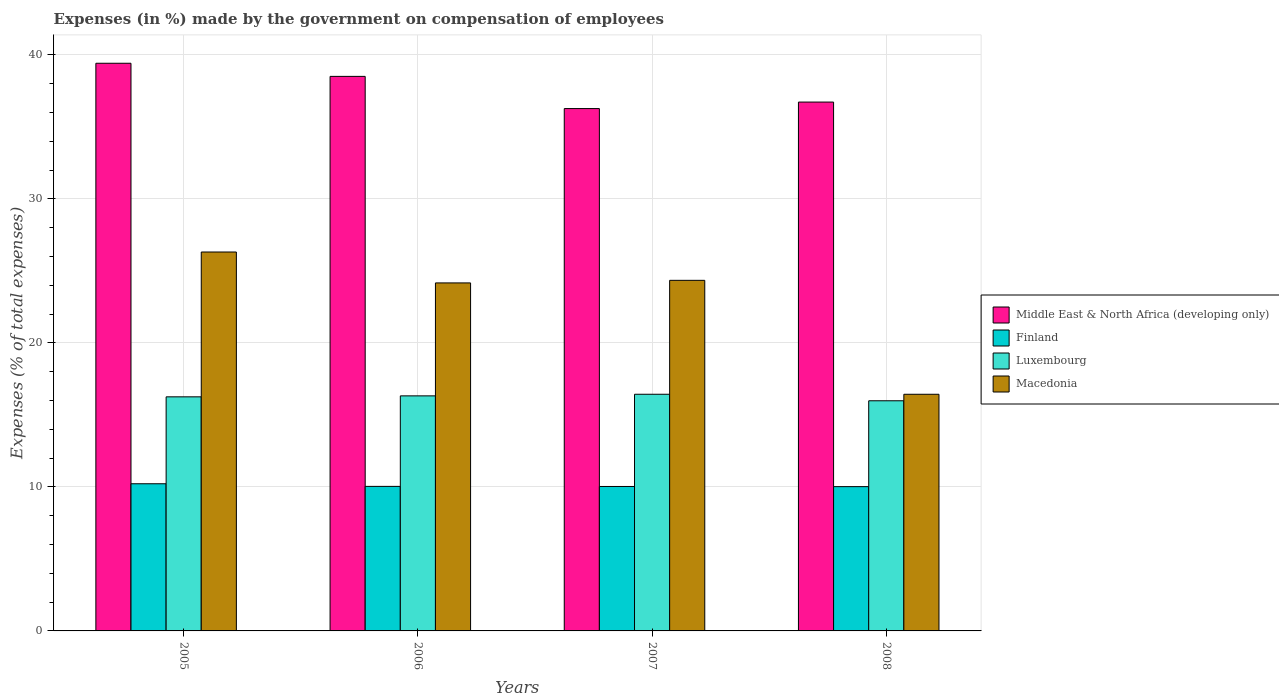Are the number of bars per tick equal to the number of legend labels?
Keep it short and to the point. Yes. Are the number of bars on each tick of the X-axis equal?
Offer a terse response. Yes. How many bars are there on the 4th tick from the right?
Keep it short and to the point. 4. In how many cases, is the number of bars for a given year not equal to the number of legend labels?
Your answer should be very brief. 0. What is the percentage of expenses made by the government on compensation of employees in Middle East & North Africa (developing only) in 2008?
Provide a succinct answer. 36.72. Across all years, what is the maximum percentage of expenses made by the government on compensation of employees in Luxembourg?
Provide a succinct answer. 16.43. Across all years, what is the minimum percentage of expenses made by the government on compensation of employees in Luxembourg?
Offer a terse response. 15.98. In which year was the percentage of expenses made by the government on compensation of employees in Luxembourg maximum?
Offer a very short reply. 2007. In which year was the percentage of expenses made by the government on compensation of employees in Macedonia minimum?
Offer a very short reply. 2008. What is the total percentage of expenses made by the government on compensation of employees in Luxembourg in the graph?
Your answer should be very brief. 64.99. What is the difference between the percentage of expenses made by the government on compensation of employees in Macedonia in 2005 and that in 2008?
Offer a very short reply. 9.88. What is the difference between the percentage of expenses made by the government on compensation of employees in Middle East & North Africa (developing only) in 2008 and the percentage of expenses made by the government on compensation of employees in Finland in 2006?
Keep it short and to the point. 26.68. What is the average percentage of expenses made by the government on compensation of employees in Finland per year?
Make the answer very short. 10.08. In the year 2005, what is the difference between the percentage of expenses made by the government on compensation of employees in Middle East & North Africa (developing only) and percentage of expenses made by the government on compensation of employees in Luxembourg?
Provide a succinct answer. 23.16. What is the ratio of the percentage of expenses made by the government on compensation of employees in Middle East & North Africa (developing only) in 2006 to that in 2007?
Give a very brief answer. 1.06. What is the difference between the highest and the second highest percentage of expenses made by the government on compensation of employees in Middle East & North Africa (developing only)?
Keep it short and to the point. 0.91. What is the difference between the highest and the lowest percentage of expenses made by the government on compensation of employees in Luxembourg?
Ensure brevity in your answer.  0.45. In how many years, is the percentage of expenses made by the government on compensation of employees in Luxembourg greater than the average percentage of expenses made by the government on compensation of employees in Luxembourg taken over all years?
Offer a very short reply. 3. Is the sum of the percentage of expenses made by the government on compensation of employees in Middle East & North Africa (developing only) in 2005 and 2007 greater than the maximum percentage of expenses made by the government on compensation of employees in Macedonia across all years?
Offer a terse response. Yes. What does the 1st bar from the left in 2005 represents?
Provide a short and direct response. Middle East & North Africa (developing only). What does the 2nd bar from the right in 2006 represents?
Your response must be concise. Luxembourg. Are all the bars in the graph horizontal?
Your answer should be very brief. No. Does the graph contain grids?
Keep it short and to the point. Yes. What is the title of the graph?
Keep it short and to the point. Expenses (in %) made by the government on compensation of employees. What is the label or title of the X-axis?
Your answer should be compact. Years. What is the label or title of the Y-axis?
Offer a terse response. Expenses (% of total expenses). What is the Expenses (% of total expenses) in Middle East & North Africa (developing only) in 2005?
Provide a short and direct response. 39.41. What is the Expenses (% of total expenses) in Finland in 2005?
Your answer should be very brief. 10.22. What is the Expenses (% of total expenses) of Luxembourg in 2005?
Your answer should be compact. 16.25. What is the Expenses (% of total expenses) in Macedonia in 2005?
Offer a terse response. 26.31. What is the Expenses (% of total expenses) in Middle East & North Africa (developing only) in 2006?
Your answer should be very brief. 38.5. What is the Expenses (% of total expenses) in Finland in 2006?
Make the answer very short. 10.04. What is the Expenses (% of total expenses) in Luxembourg in 2006?
Your answer should be very brief. 16.32. What is the Expenses (% of total expenses) in Macedonia in 2006?
Your response must be concise. 24.16. What is the Expenses (% of total expenses) of Middle East & North Africa (developing only) in 2007?
Give a very brief answer. 36.27. What is the Expenses (% of total expenses) of Finland in 2007?
Your answer should be very brief. 10.03. What is the Expenses (% of total expenses) in Luxembourg in 2007?
Your answer should be compact. 16.43. What is the Expenses (% of total expenses) in Macedonia in 2007?
Provide a short and direct response. 24.34. What is the Expenses (% of total expenses) in Middle East & North Africa (developing only) in 2008?
Offer a terse response. 36.72. What is the Expenses (% of total expenses) in Finland in 2008?
Ensure brevity in your answer.  10.02. What is the Expenses (% of total expenses) of Luxembourg in 2008?
Ensure brevity in your answer.  15.98. What is the Expenses (% of total expenses) in Macedonia in 2008?
Give a very brief answer. 16.43. Across all years, what is the maximum Expenses (% of total expenses) of Middle East & North Africa (developing only)?
Offer a very short reply. 39.41. Across all years, what is the maximum Expenses (% of total expenses) of Finland?
Provide a succinct answer. 10.22. Across all years, what is the maximum Expenses (% of total expenses) of Luxembourg?
Give a very brief answer. 16.43. Across all years, what is the maximum Expenses (% of total expenses) in Macedonia?
Keep it short and to the point. 26.31. Across all years, what is the minimum Expenses (% of total expenses) in Middle East & North Africa (developing only)?
Keep it short and to the point. 36.27. Across all years, what is the minimum Expenses (% of total expenses) in Finland?
Keep it short and to the point. 10.02. Across all years, what is the minimum Expenses (% of total expenses) of Luxembourg?
Offer a very short reply. 15.98. Across all years, what is the minimum Expenses (% of total expenses) of Macedonia?
Make the answer very short. 16.43. What is the total Expenses (% of total expenses) of Middle East & North Africa (developing only) in the graph?
Give a very brief answer. 150.91. What is the total Expenses (% of total expenses) of Finland in the graph?
Keep it short and to the point. 40.3. What is the total Expenses (% of total expenses) in Luxembourg in the graph?
Your response must be concise. 64.99. What is the total Expenses (% of total expenses) of Macedonia in the graph?
Make the answer very short. 91.25. What is the difference between the Expenses (% of total expenses) in Middle East & North Africa (developing only) in 2005 and that in 2006?
Provide a short and direct response. 0.91. What is the difference between the Expenses (% of total expenses) of Finland in 2005 and that in 2006?
Provide a short and direct response. 0.18. What is the difference between the Expenses (% of total expenses) in Luxembourg in 2005 and that in 2006?
Your answer should be very brief. -0.07. What is the difference between the Expenses (% of total expenses) in Macedonia in 2005 and that in 2006?
Provide a short and direct response. 2.15. What is the difference between the Expenses (% of total expenses) in Middle East & North Africa (developing only) in 2005 and that in 2007?
Offer a very short reply. 3.15. What is the difference between the Expenses (% of total expenses) in Finland in 2005 and that in 2007?
Keep it short and to the point. 0.19. What is the difference between the Expenses (% of total expenses) of Luxembourg in 2005 and that in 2007?
Offer a terse response. -0.18. What is the difference between the Expenses (% of total expenses) in Macedonia in 2005 and that in 2007?
Make the answer very short. 1.97. What is the difference between the Expenses (% of total expenses) in Middle East & North Africa (developing only) in 2005 and that in 2008?
Ensure brevity in your answer.  2.69. What is the difference between the Expenses (% of total expenses) in Finland in 2005 and that in 2008?
Provide a succinct answer. 0.2. What is the difference between the Expenses (% of total expenses) in Luxembourg in 2005 and that in 2008?
Your response must be concise. 0.27. What is the difference between the Expenses (% of total expenses) of Macedonia in 2005 and that in 2008?
Your response must be concise. 9.88. What is the difference between the Expenses (% of total expenses) of Middle East & North Africa (developing only) in 2006 and that in 2007?
Your response must be concise. 2.23. What is the difference between the Expenses (% of total expenses) in Finland in 2006 and that in 2007?
Your response must be concise. 0.01. What is the difference between the Expenses (% of total expenses) of Luxembourg in 2006 and that in 2007?
Keep it short and to the point. -0.11. What is the difference between the Expenses (% of total expenses) of Macedonia in 2006 and that in 2007?
Ensure brevity in your answer.  -0.18. What is the difference between the Expenses (% of total expenses) in Middle East & North Africa (developing only) in 2006 and that in 2008?
Give a very brief answer. 1.78. What is the difference between the Expenses (% of total expenses) in Finland in 2006 and that in 2008?
Make the answer very short. 0.02. What is the difference between the Expenses (% of total expenses) in Luxembourg in 2006 and that in 2008?
Your answer should be compact. 0.34. What is the difference between the Expenses (% of total expenses) of Macedonia in 2006 and that in 2008?
Your answer should be very brief. 7.73. What is the difference between the Expenses (% of total expenses) in Middle East & North Africa (developing only) in 2007 and that in 2008?
Your response must be concise. -0.45. What is the difference between the Expenses (% of total expenses) of Finland in 2007 and that in 2008?
Offer a very short reply. 0.01. What is the difference between the Expenses (% of total expenses) in Luxembourg in 2007 and that in 2008?
Offer a very short reply. 0.45. What is the difference between the Expenses (% of total expenses) of Macedonia in 2007 and that in 2008?
Provide a succinct answer. 7.91. What is the difference between the Expenses (% of total expenses) in Middle East & North Africa (developing only) in 2005 and the Expenses (% of total expenses) in Finland in 2006?
Give a very brief answer. 29.38. What is the difference between the Expenses (% of total expenses) in Middle East & North Africa (developing only) in 2005 and the Expenses (% of total expenses) in Luxembourg in 2006?
Provide a succinct answer. 23.09. What is the difference between the Expenses (% of total expenses) of Middle East & North Africa (developing only) in 2005 and the Expenses (% of total expenses) of Macedonia in 2006?
Give a very brief answer. 15.25. What is the difference between the Expenses (% of total expenses) in Finland in 2005 and the Expenses (% of total expenses) in Luxembourg in 2006?
Keep it short and to the point. -6.1. What is the difference between the Expenses (% of total expenses) in Finland in 2005 and the Expenses (% of total expenses) in Macedonia in 2006?
Your answer should be very brief. -13.95. What is the difference between the Expenses (% of total expenses) of Luxembourg in 2005 and the Expenses (% of total expenses) of Macedonia in 2006?
Your answer should be compact. -7.91. What is the difference between the Expenses (% of total expenses) in Middle East & North Africa (developing only) in 2005 and the Expenses (% of total expenses) in Finland in 2007?
Offer a very short reply. 29.39. What is the difference between the Expenses (% of total expenses) in Middle East & North Africa (developing only) in 2005 and the Expenses (% of total expenses) in Luxembourg in 2007?
Offer a terse response. 22.98. What is the difference between the Expenses (% of total expenses) in Middle East & North Africa (developing only) in 2005 and the Expenses (% of total expenses) in Macedonia in 2007?
Provide a short and direct response. 15.07. What is the difference between the Expenses (% of total expenses) in Finland in 2005 and the Expenses (% of total expenses) in Luxembourg in 2007?
Make the answer very short. -6.21. What is the difference between the Expenses (% of total expenses) of Finland in 2005 and the Expenses (% of total expenses) of Macedonia in 2007?
Offer a terse response. -14.12. What is the difference between the Expenses (% of total expenses) in Luxembourg in 2005 and the Expenses (% of total expenses) in Macedonia in 2007?
Offer a terse response. -8.09. What is the difference between the Expenses (% of total expenses) of Middle East & North Africa (developing only) in 2005 and the Expenses (% of total expenses) of Finland in 2008?
Offer a terse response. 29.4. What is the difference between the Expenses (% of total expenses) of Middle East & North Africa (developing only) in 2005 and the Expenses (% of total expenses) of Luxembourg in 2008?
Keep it short and to the point. 23.44. What is the difference between the Expenses (% of total expenses) of Middle East & North Africa (developing only) in 2005 and the Expenses (% of total expenses) of Macedonia in 2008?
Your answer should be compact. 22.98. What is the difference between the Expenses (% of total expenses) of Finland in 2005 and the Expenses (% of total expenses) of Luxembourg in 2008?
Give a very brief answer. -5.76. What is the difference between the Expenses (% of total expenses) in Finland in 2005 and the Expenses (% of total expenses) in Macedonia in 2008?
Ensure brevity in your answer.  -6.21. What is the difference between the Expenses (% of total expenses) in Luxembourg in 2005 and the Expenses (% of total expenses) in Macedonia in 2008?
Keep it short and to the point. -0.18. What is the difference between the Expenses (% of total expenses) in Middle East & North Africa (developing only) in 2006 and the Expenses (% of total expenses) in Finland in 2007?
Make the answer very short. 28.47. What is the difference between the Expenses (% of total expenses) in Middle East & North Africa (developing only) in 2006 and the Expenses (% of total expenses) in Luxembourg in 2007?
Your answer should be compact. 22.07. What is the difference between the Expenses (% of total expenses) of Middle East & North Africa (developing only) in 2006 and the Expenses (% of total expenses) of Macedonia in 2007?
Give a very brief answer. 14.16. What is the difference between the Expenses (% of total expenses) in Finland in 2006 and the Expenses (% of total expenses) in Luxembourg in 2007?
Offer a very short reply. -6.4. What is the difference between the Expenses (% of total expenses) of Finland in 2006 and the Expenses (% of total expenses) of Macedonia in 2007?
Give a very brief answer. -14.31. What is the difference between the Expenses (% of total expenses) in Luxembourg in 2006 and the Expenses (% of total expenses) in Macedonia in 2007?
Keep it short and to the point. -8.02. What is the difference between the Expenses (% of total expenses) of Middle East & North Africa (developing only) in 2006 and the Expenses (% of total expenses) of Finland in 2008?
Your answer should be compact. 28.49. What is the difference between the Expenses (% of total expenses) in Middle East & North Africa (developing only) in 2006 and the Expenses (% of total expenses) in Luxembourg in 2008?
Make the answer very short. 22.52. What is the difference between the Expenses (% of total expenses) in Middle East & North Africa (developing only) in 2006 and the Expenses (% of total expenses) in Macedonia in 2008?
Provide a short and direct response. 22.07. What is the difference between the Expenses (% of total expenses) in Finland in 2006 and the Expenses (% of total expenses) in Luxembourg in 2008?
Your answer should be compact. -5.94. What is the difference between the Expenses (% of total expenses) in Finland in 2006 and the Expenses (% of total expenses) in Macedonia in 2008?
Make the answer very short. -6.4. What is the difference between the Expenses (% of total expenses) of Luxembourg in 2006 and the Expenses (% of total expenses) of Macedonia in 2008?
Provide a short and direct response. -0.11. What is the difference between the Expenses (% of total expenses) of Middle East & North Africa (developing only) in 2007 and the Expenses (% of total expenses) of Finland in 2008?
Your answer should be compact. 26.25. What is the difference between the Expenses (% of total expenses) in Middle East & North Africa (developing only) in 2007 and the Expenses (% of total expenses) in Luxembourg in 2008?
Give a very brief answer. 20.29. What is the difference between the Expenses (% of total expenses) in Middle East & North Africa (developing only) in 2007 and the Expenses (% of total expenses) in Macedonia in 2008?
Offer a very short reply. 19.84. What is the difference between the Expenses (% of total expenses) in Finland in 2007 and the Expenses (% of total expenses) in Luxembourg in 2008?
Your answer should be compact. -5.95. What is the difference between the Expenses (% of total expenses) of Finland in 2007 and the Expenses (% of total expenses) of Macedonia in 2008?
Your response must be concise. -6.4. What is the average Expenses (% of total expenses) in Middle East & North Africa (developing only) per year?
Ensure brevity in your answer.  37.73. What is the average Expenses (% of total expenses) in Finland per year?
Make the answer very short. 10.08. What is the average Expenses (% of total expenses) in Luxembourg per year?
Give a very brief answer. 16.25. What is the average Expenses (% of total expenses) of Macedonia per year?
Ensure brevity in your answer.  22.81. In the year 2005, what is the difference between the Expenses (% of total expenses) of Middle East & North Africa (developing only) and Expenses (% of total expenses) of Finland?
Your response must be concise. 29.2. In the year 2005, what is the difference between the Expenses (% of total expenses) of Middle East & North Africa (developing only) and Expenses (% of total expenses) of Luxembourg?
Ensure brevity in your answer.  23.16. In the year 2005, what is the difference between the Expenses (% of total expenses) in Middle East & North Africa (developing only) and Expenses (% of total expenses) in Macedonia?
Provide a succinct answer. 13.11. In the year 2005, what is the difference between the Expenses (% of total expenses) in Finland and Expenses (% of total expenses) in Luxembourg?
Provide a succinct answer. -6.04. In the year 2005, what is the difference between the Expenses (% of total expenses) in Finland and Expenses (% of total expenses) in Macedonia?
Your response must be concise. -16.09. In the year 2005, what is the difference between the Expenses (% of total expenses) in Luxembourg and Expenses (% of total expenses) in Macedonia?
Provide a short and direct response. -10.06. In the year 2006, what is the difference between the Expenses (% of total expenses) in Middle East & North Africa (developing only) and Expenses (% of total expenses) in Finland?
Provide a succinct answer. 28.47. In the year 2006, what is the difference between the Expenses (% of total expenses) in Middle East & North Africa (developing only) and Expenses (% of total expenses) in Luxembourg?
Your answer should be very brief. 22.18. In the year 2006, what is the difference between the Expenses (% of total expenses) in Middle East & North Africa (developing only) and Expenses (% of total expenses) in Macedonia?
Your answer should be compact. 14.34. In the year 2006, what is the difference between the Expenses (% of total expenses) of Finland and Expenses (% of total expenses) of Luxembourg?
Provide a succinct answer. -6.29. In the year 2006, what is the difference between the Expenses (% of total expenses) of Finland and Expenses (% of total expenses) of Macedonia?
Offer a very short reply. -14.13. In the year 2006, what is the difference between the Expenses (% of total expenses) of Luxembourg and Expenses (% of total expenses) of Macedonia?
Provide a succinct answer. -7.84. In the year 2007, what is the difference between the Expenses (% of total expenses) in Middle East & North Africa (developing only) and Expenses (% of total expenses) in Finland?
Your answer should be compact. 26.24. In the year 2007, what is the difference between the Expenses (% of total expenses) of Middle East & North Africa (developing only) and Expenses (% of total expenses) of Luxembourg?
Ensure brevity in your answer.  19.84. In the year 2007, what is the difference between the Expenses (% of total expenses) of Middle East & North Africa (developing only) and Expenses (% of total expenses) of Macedonia?
Your response must be concise. 11.93. In the year 2007, what is the difference between the Expenses (% of total expenses) in Finland and Expenses (% of total expenses) in Luxembourg?
Provide a short and direct response. -6.4. In the year 2007, what is the difference between the Expenses (% of total expenses) of Finland and Expenses (% of total expenses) of Macedonia?
Give a very brief answer. -14.31. In the year 2007, what is the difference between the Expenses (% of total expenses) in Luxembourg and Expenses (% of total expenses) in Macedonia?
Your answer should be very brief. -7.91. In the year 2008, what is the difference between the Expenses (% of total expenses) in Middle East & North Africa (developing only) and Expenses (% of total expenses) in Finland?
Your answer should be very brief. 26.7. In the year 2008, what is the difference between the Expenses (% of total expenses) of Middle East & North Africa (developing only) and Expenses (% of total expenses) of Luxembourg?
Provide a short and direct response. 20.74. In the year 2008, what is the difference between the Expenses (% of total expenses) in Middle East & North Africa (developing only) and Expenses (% of total expenses) in Macedonia?
Provide a succinct answer. 20.29. In the year 2008, what is the difference between the Expenses (% of total expenses) in Finland and Expenses (% of total expenses) in Luxembourg?
Offer a terse response. -5.96. In the year 2008, what is the difference between the Expenses (% of total expenses) in Finland and Expenses (% of total expenses) in Macedonia?
Your answer should be very brief. -6.41. In the year 2008, what is the difference between the Expenses (% of total expenses) of Luxembourg and Expenses (% of total expenses) of Macedonia?
Your answer should be very brief. -0.45. What is the ratio of the Expenses (% of total expenses) in Middle East & North Africa (developing only) in 2005 to that in 2006?
Your answer should be very brief. 1.02. What is the ratio of the Expenses (% of total expenses) of Finland in 2005 to that in 2006?
Your answer should be very brief. 1.02. What is the ratio of the Expenses (% of total expenses) of Luxembourg in 2005 to that in 2006?
Make the answer very short. 1. What is the ratio of the Expenses (% of total expenses) in Macedonia in 2005 to that in 2006?
Give a very brief answer. 1.09. What is the ratio of the Expenses (% of total expenses) in Middle East & North Africa (developing only) in 2005 to that in 2007?
Your response must be concise. 1.09. What is the ratio of the Expenses (% of total expenses) of Finland in 2005 to that in 2007?
Provide a succinct answer. 1.02. What is the ratio of the Expenses (% of total expenses) of Luxembourg in 2005 to that in 2007?
Keep it short and to the point. 0.99. What is the ratio of the Expenses (% of total expenses) in Macedonia in 2005 to that in 2007?
Give a very brief answer. 1.08. What is the ratio of the Expenses (% of total expenses) in Middle East & North Africa (developing only) in 2005 to that in 2008?
Make the answer very short. 1.07. What is the ratio of the Expenses (% of total expenses) of Finland in 2005 to that in 2008?
Provide a succinct answer. 1.02. What is the ratio of the Expenses (% of total expenses) of Luxembourg in 2005 to that in 2008?
Offer a very short reply. 1.02. What is the ratio of the Expenses (% of total expenses) of Macedonia in 2005 to that in 2008?
Your response must be concise. 1.6. What is the ratio of the Expenses (% of total expenses) of Middle East & North Africa (developing only) in 2006 to that in 2007?
Your answer should be compact. 1.06. What is the ratio of the Expenses (% of total expenses) in Finland in 2006 to that in 2007?
Make the answer very short. 1. What is the ratio of the Expenses (% of total expenses) in Luxembourg in 2006 to that in 2007?
Keep it short and to the point. 0.99. What is the ratio of the Expenses (% of total expenses) in Macedonia in 2006 to that in 2007?
Your response must be concise. 0.99. What is the ratio of the Expenses (% of total expenses) of Middle East & North Africa (developing only) in 2006 to that in 2008?
Your response must be concise. 1.05. What is the ratio of the Expenses (% of total expenses) in Luxembourg in 2006 to that in 2008?
Provide a succinct answer. 1.02. What is the ratio of the Expenses (% of total expenses) of Macedonia in 2006 to that in 2008?
Offer a terse response. 1.47. What is the ratio of the Expenses (% of total expenses) of Finland in 2007 to that in 2008?
Provide a short and direct response. 1. What is the ratio of the Expenses (% of total expenses) of Luxembourg in 2007 to that in 2008?
Ensure brevity in your answer.  1.03. What is the ratio of the Expenses (% of total expenses) of Macedonia in 2007 to that in 2008?
Keep it short and to the point. 1.48. What is the difference between the highest and the second highest Expenses (% of total expenses) in Middle East & North Africa (developing only)?
Provide a succinct answer. 0.91. What is the difference between the highest and the second highest Expenses (% of total expenses) of Finland?
Keep it short and to the point. 0.18. What is the difference between the highest and the second highest Expenses (% of total expenses) of Luxembourg?
Ensure brevity in your answer.  0.11. What is the difference between the highest and the second highest Expenses (% of total expenses) in Macedonia?
Provide a short and direct response. 1.97. What is the difference between the highest and the lowest Expenses (% of total expenses) in Middle East & North Africa (developing only)?
Your answer should be compact. 3.15. What is the difference between the highest and the lowest Expenses (% of total expenses) in Finland?
Provide a short and direct response. 0.2. What is the difference between the highest and the lowest Expenses (% of total expenses) of Luxembourg?
Keep it short and to the point. 0.45. What is the difference between the highest and the lowest Expenses (% of total expenses) of Macedonia?
Provide a short and direct response. 9.88. 